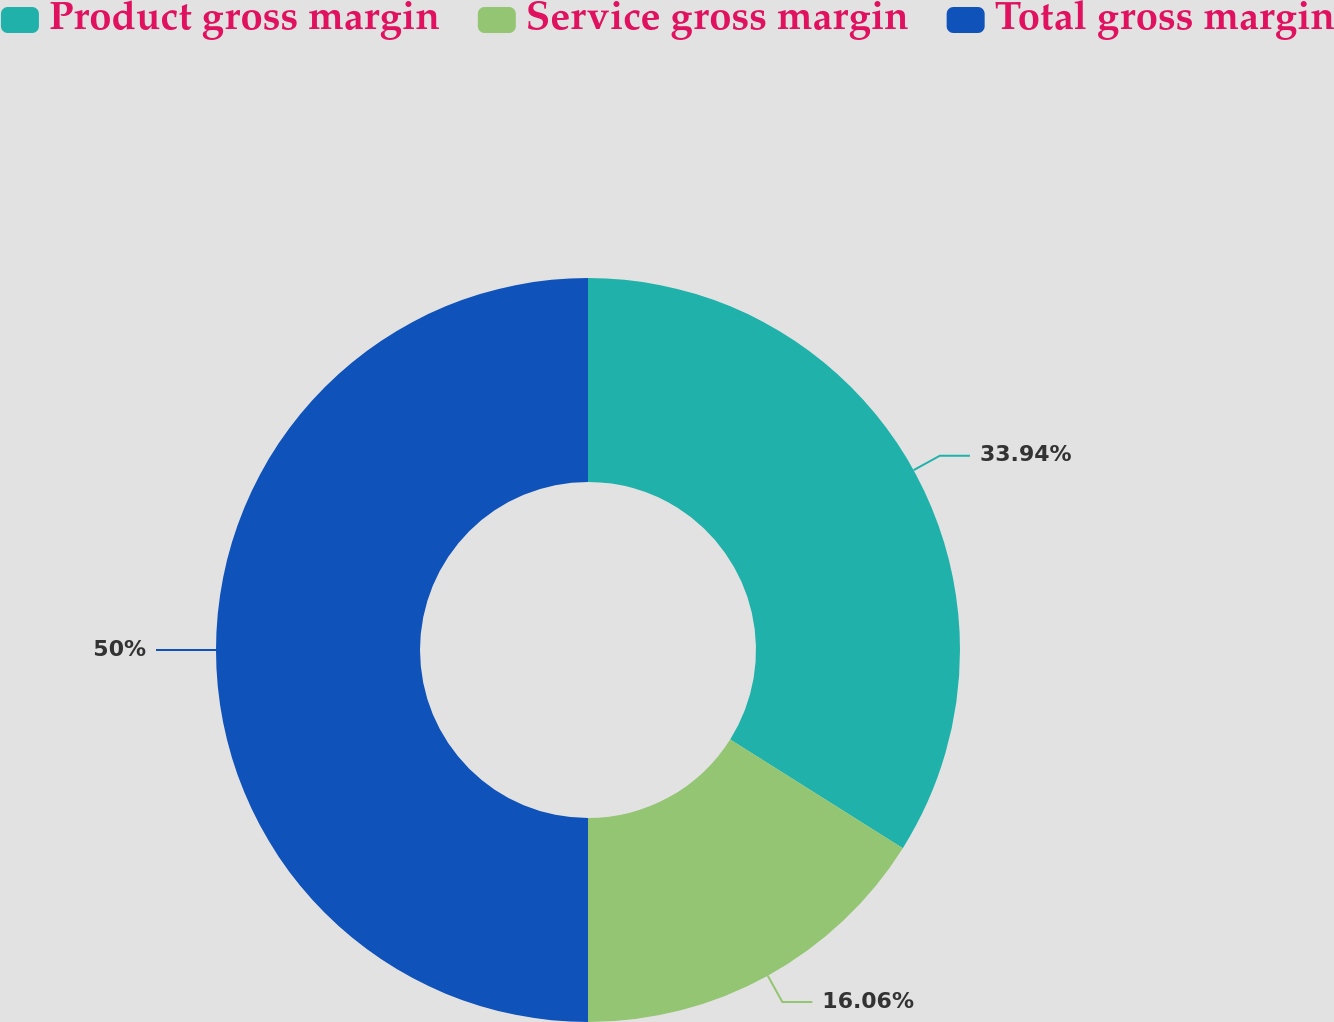<chart> <loc_0><loc_0><loc_500><loc_500><pie_chart><fcel>Product gross margin<fcel>Service gross margin<fcel>Total gross margin<nl><fcel>33.94%<fcel>16.06%<fcel>50.0%<nl></chart> 